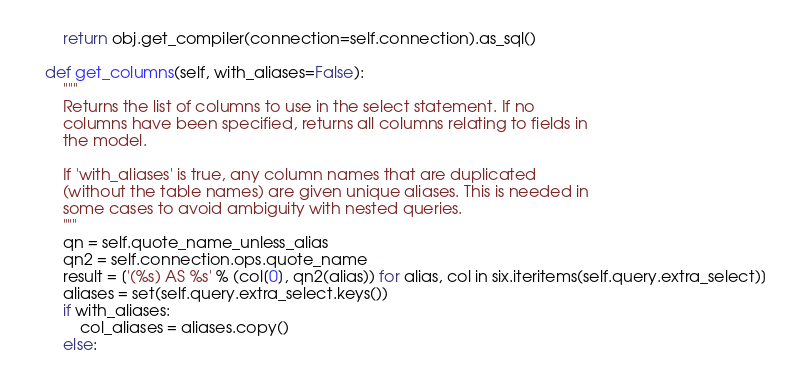<code> <loc_0><loc_0><loc_500><loc_500><_Python_>        return obj.get_compiler(connection=self.connection).as_sql()

    def get_columns(self, with_aliases=False):
        """
        Returns the list of columns to use in the select statement. If no
        columns have been specified, returns all columns relating to fields in
        the model.

        If 'with_aliases' is true, any column names that are duplicated
        (without the table names) are given unique aliases. This is needed in
        some cases to avoid ambiguity with nested queries.
        """
        qn = self.quote_name_unless_alias
        qn2 = self.connection.ops.quote_name
        result = ['(%s) AS %s' % (col[0], qn2(alias)) for alias, col in six.iteritems(self.query.extra_select)]
        aliases = set(self.query.extra_select.keys())
        if with_aliases:
            col_aliases = aliases.copy()
        else:</code> 